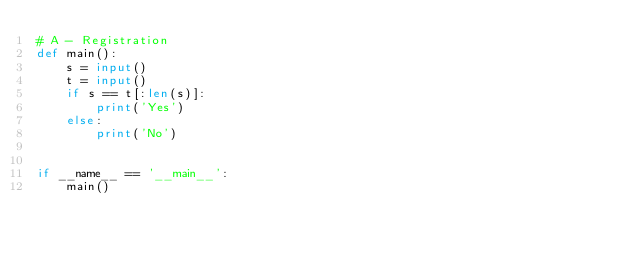<code> <loc_0><loc_0><loc_500><loc_500><_Python_># A - Registration
def main():
    s = input()
    t = input()
    if s == t[:len(s)]:
        print('Yes')
    else:
        print('No')


if __name__ == '__main__':
    main()</code> 